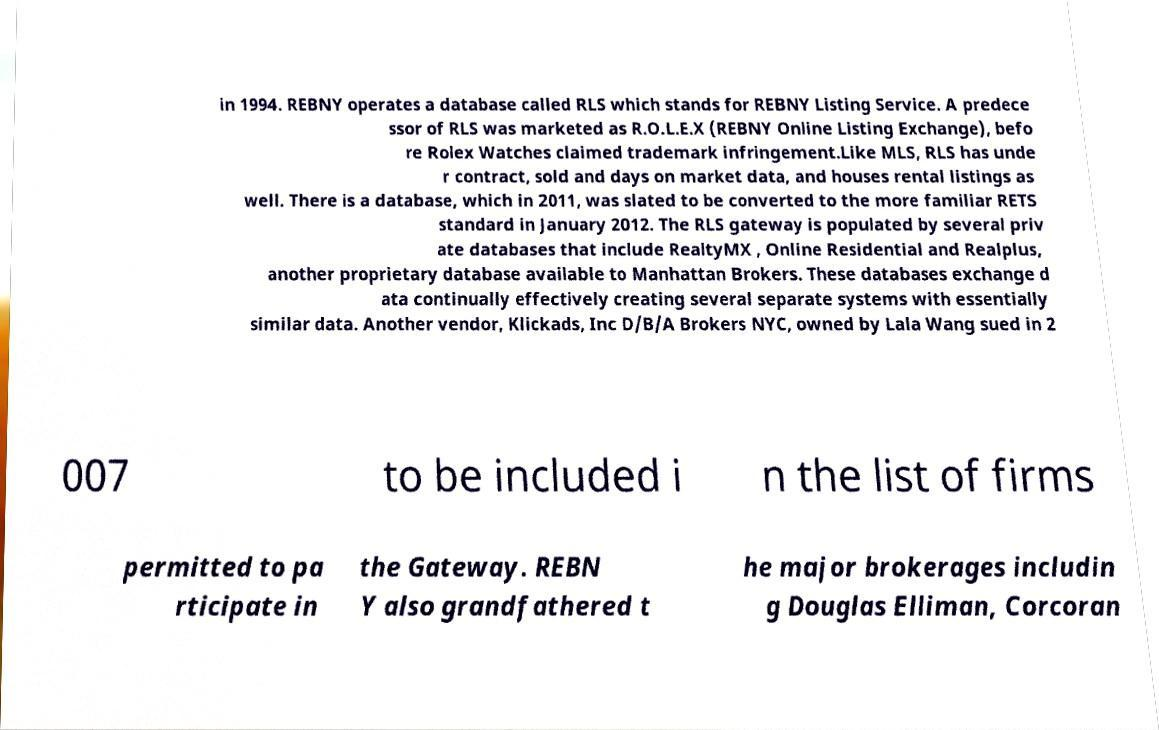Could you extract and type out the text from this image? in 1994. REBNY operates a database called RLS which stands for REBNY Listing Service. A predece ssor of RLS was marketed as R.O.L.E.X (REBNY Online Listing Exchange), befo re Rolex Watches claimed trademark infringement.Like MLS, RLS has unde r contract, sold and days on market data, and houses rental listings as well. There is a database, which in 2011, was slated to be converted to the more familiar RETS standard in January 2012. The RLS gateway is populated by several priv ate databases that include RealtyMX , Online Residential and Realplus, another proprietary database available to Manhattan Brokers. These databases exchange d ata continually effectively creating several separate systems with essentially similar data. Another vendor, Klickads, Inc D/B/A Brokers NYC, owned by Lala Wang sued in 2 007 to be included i n the list of firms permitted to pa rticipate in the Gateway. REBN Y also grandfathered t he major brokerages includin g Douglas Elliman, Corcoran 